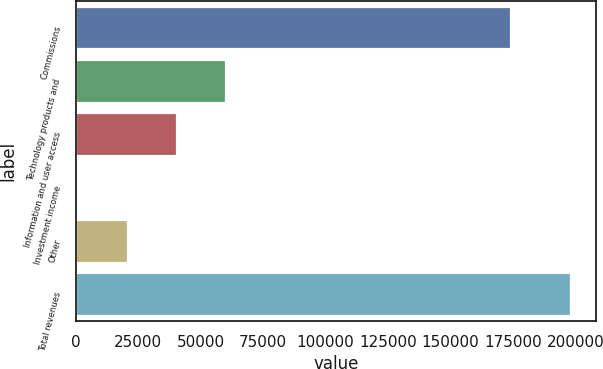Convert chart. <chart><loc_0><loc_0><loc_500><loc_500><bar_chart><fcel>Commissions<fcel>Technology products and<fcel>Information and user access<fcel>Investment income<fcel>Other<fcel>Total revenues<nl><fcel>174199<fcel>60201.8<fcel>40487.2<fcel>1058<fcel>20772.6<fcel>198204<nl></chart> 